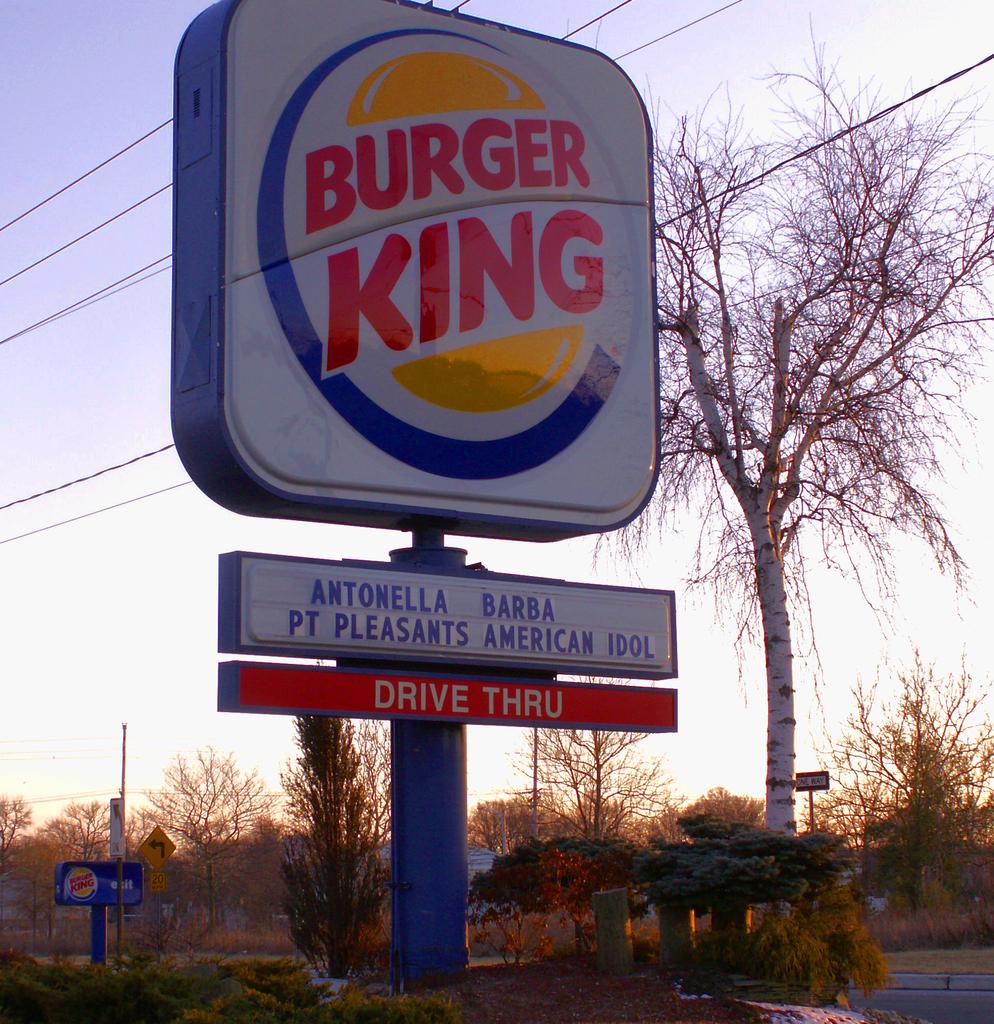Does burger king sponsor american idol?
Ensure brevity in your answer.  Yes. Does this burger king have a drive thru?
Your answer should be very brief. Yes. 